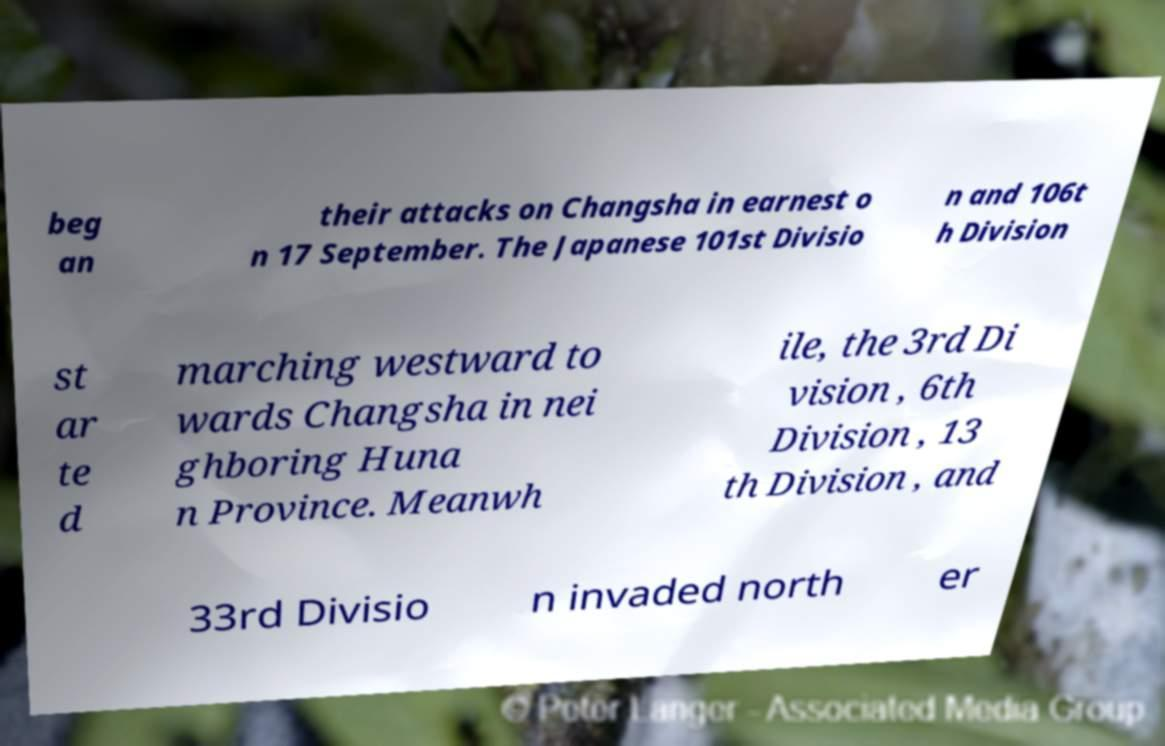Please identify and transcribe the text found in this image. beg an their attacks on Changsha in earnest o n 17 September. The Japanese 101st Divisio n and 106t h Division st ar te d marching westward to wards Changsha in nei ghboring Huna n Province. Meanwh ile, the 3rd Di vision , 6th Division , 13 th Division , and 33rd Divisio n invaded north er 